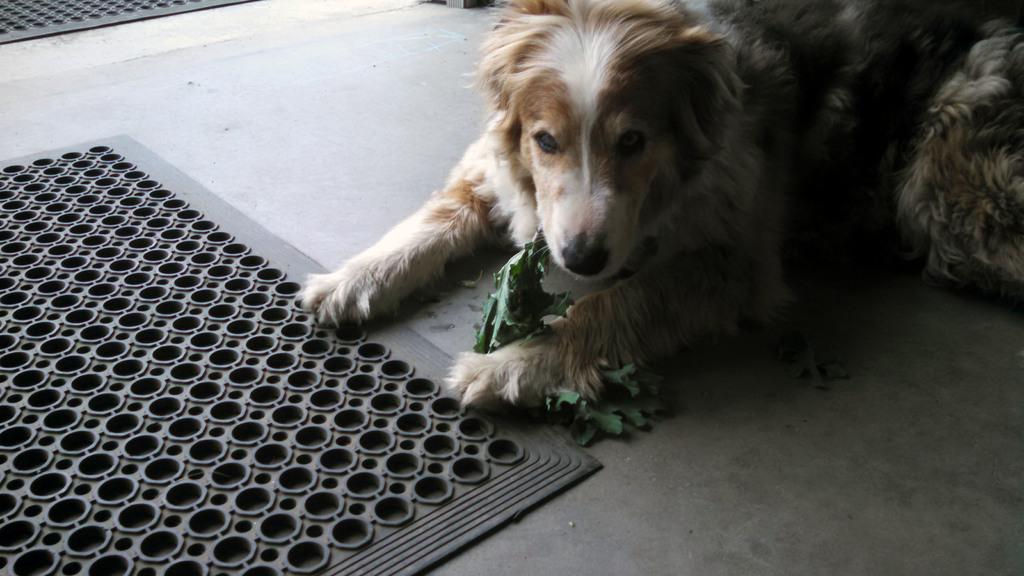Describe this image in one or two sentences. In this picture we can see a dog holding leaves and we can see mars on the floor. 